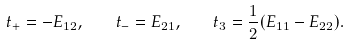Convert formula to latex. <formula><loc_0><loc_0><loc_500><loc_500>t _ { + } = - E _ { 1 2 } , \quad t _ { - } = E _ { 2 1 } , \quad t _ { 3 } = \frac { 1 } { 2 } ( E _ { 1 1 } - E _ { 2 2 } ) .</formula> 